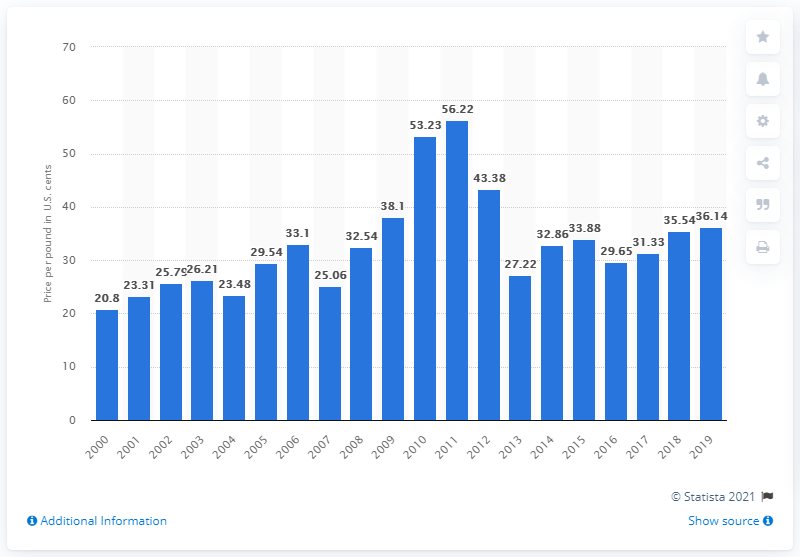Draw attention to some important aspects in this diagram. In 2019, the cost of one pound of refined sugar beet in the US was $36.14. In 2014, the price of sugar beet per pound was 32.86. 